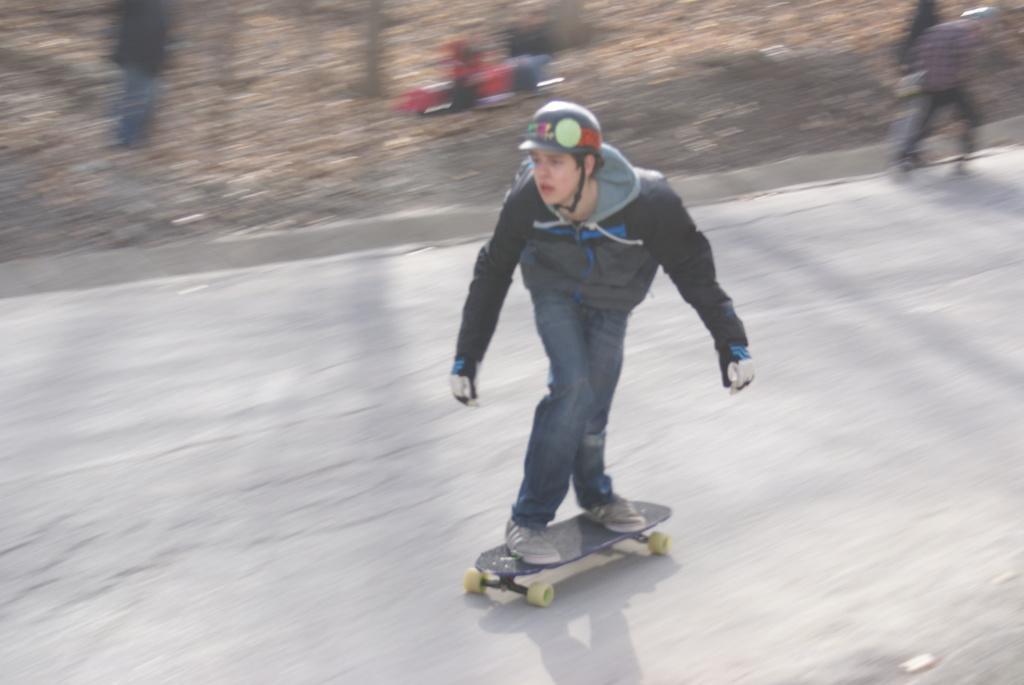Describe this image in one or two sentences. In this image there is a person on the skateboard and he is wearing the helmet. At the bottom of the image there is a road. In the background of the image there are people and there is some object. 